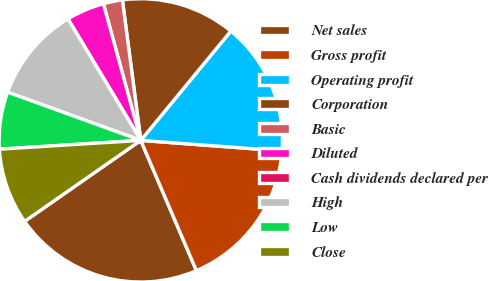Convert chart to OTSL. <chart><loc_0><loc_0><loc_500><loc_500><pie_chart><fcel>Net sales<fcel>Gross profit<fcel>Operating profit<fcel>Corporation<fcel>Basic<fcel>Diluted<fcel>Cash dividends declared per<fcel>High<fcel>Low<fcel>Close<nl><fcel>21.74%<fcel>17.39%<fcel>15.22%<fcel>13.04%<fcel>2.18%<fcel>4.35%<fcel>0.0%<fcel>10.87%<fcel>6.52%<fcel>8.7%<nl></chart> 